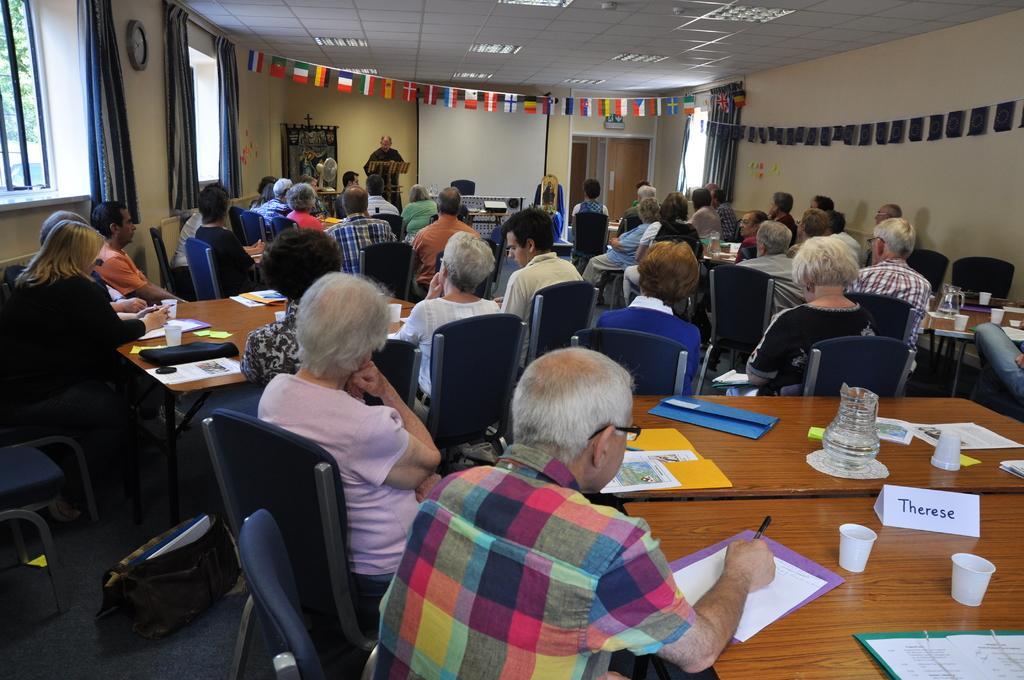How would you summarize this image in a sentence or two? This is a picture taken in a room, there are group of people sitting on chair in front of the people there is a table. The women in pink t shirt in front of the women there is a table on the table there is a file, paper, cup and a name board and the right side of the people there is a wall with a stickers. Background of this people there is a projector screen. 